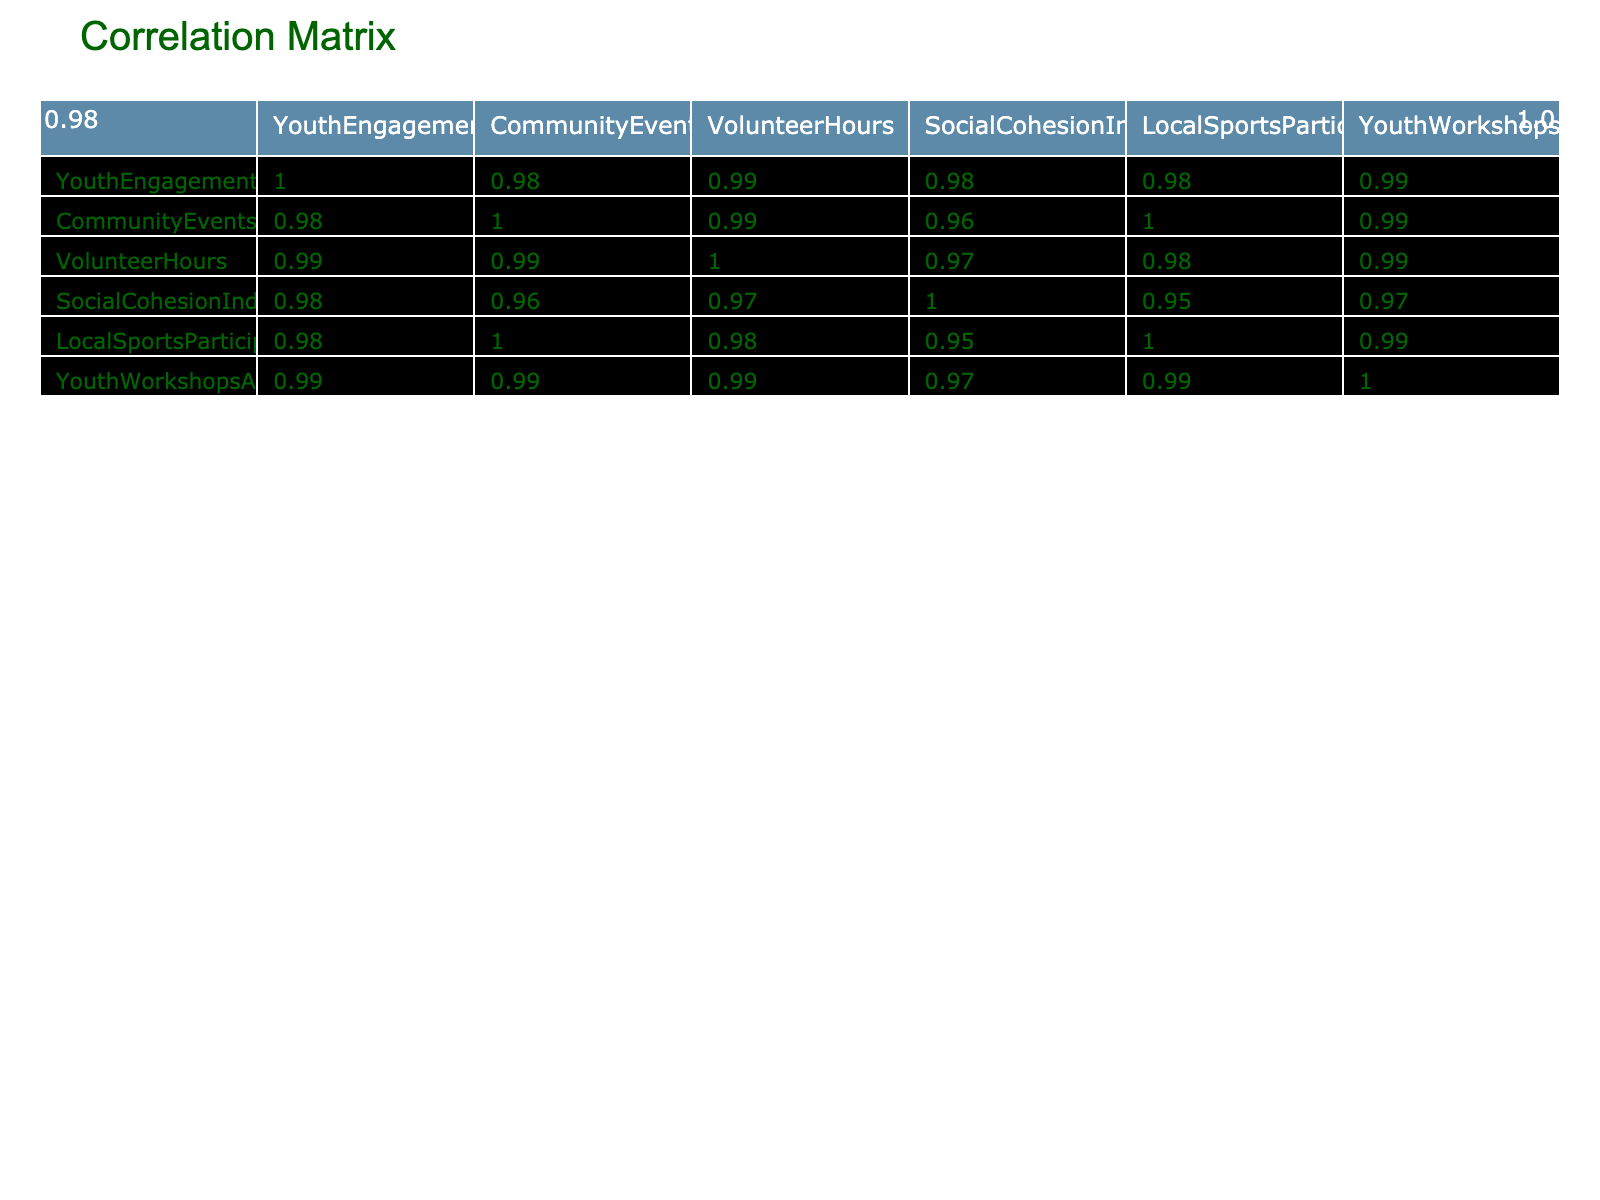What is the correlation between Youth Engagement and Social Cohesion Index? The correlation value taken from the table shows how closely related Youth Engagement is to the Social Cohesion Index. Looking at the correlation matrix, the value is 0.72, indicating a strong positive correlation.
Answer: 0.72 What is the average number of Volunteer Hours across all entries? To find the average, we need to sum the Volunteer Hours: (45 + 30 + 60 + 20 + 75 + 40 + 10 + 50 + 35 + 15) = 440. There are 10 entries, so the average is 440/10 = 44.
Answer: 44 Is there a negative correlation between Community Events Attendance and Local Sports Participation? Checking the correlation matrix reveals the relationship between these two variables. The value is -0.07, indicating that there is no significant negative correlation.
Answer: No What is the highest Social Cohesion Index recorded in the data? By scanning the Social Cohesion Index column, we can find the maximum value. The highest recorded value is 82.
Answer: 82 What is the difference between the maximum and minimum values of Youth Engagement? The maximum Youth Engagement value is 90 and the minimum is 45. To find the difference, we subtract the minimum from the maximum: 90 - 45 = 45.
Answer: 45 Is Local Sports Participation correlated positively with Volunteer Hours? Looking at the correlation matrix, the value between Local Sports Participation and Volunteer Hours is 0.63, which indicates a positive correlation.
Answer: Yes What would be the average Social Cohesion Index for youth with Youth Engagement greater than 70? We filter the entries where Youth Engagement is greater than 70: (75, 85, 90, 80). Their corresponding Social Cohesion Indices are (76, 80, 82, 78). We sum these: (76 + 80 + 82 + 78) = 316. There are 4 entries, so the average is 316/4 = 79.
Answer: 79 How many Youth Workshops were attended on average? To determine the average, sum the values in the Youth Workshops Attended column: (5 + 3 + 6 + 2 + 7 + 4 + 1 + 5 + 3 + 2) = 38. The average is 38 divided by the number of entries, 10: 38/10 = 3.8.
Answer: 3.8 Is there a strong correlation between Youth Workshops Attended and Local Sports Participation? The table shows the correlation coefficient between these two variables is 0.38, indicating a moderate positive relationship, but not a strong correlation.
Answer: No 